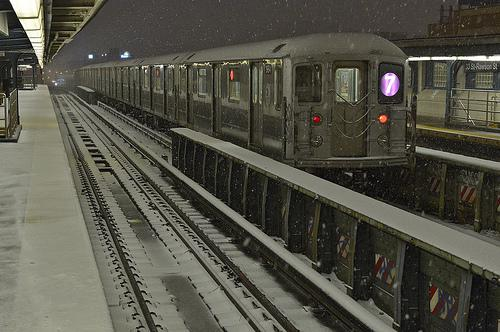Question: how much snow is on the ground?
Choices:
A. A lot.
B. A medium amount.
C. Only a little.
D. 3 feet.
Answer with the letter. Answer: C Question: who operates this vehicle?
Choices:
A. A pilot.
B. A captain.
C. An engineer.
D. A driver.
Answer with the letter. Answer: C Question: what color are the stripes on the barrier decals?
Choices:
A. Green.
B. Blue.
C. Black.
D. Red and white.
Answer with the letter. Answer: D 